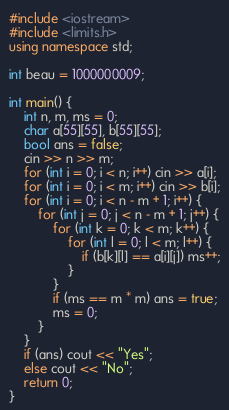<code> <loc_0><loc_0><loc_500><loc_500><_C++_>#include <iostream>
#include <limits.h>
using namespace std;

int beau = 1000000009;

int main() {
	int n, m, ms = 0;
	char a[55][55], b[55][55];
	bool ans = false;
	cin >> n >> m;
	for (int i = 0; i < n; i++) cin >> a[i];
	for (int i = 0; i < m; i++) cin >> b[i];
	for (int i = 0; i < n - m + 1; i++) {
	    for (int j = 0; j < n - m + 1; j++) {
	        for (int k = 0; k < m; k++) {
	            for (int l = 0; l < m; l++) {
	                if (b[k][l] == a[i][j]) ms++;
	            }
	        }
	        if (ms == m * m) ans = true;
	        ms = 0;
	    }
	}
	if (ans) cout << "Yes";
	else cout << "No";
	return 0;
}
</code> 